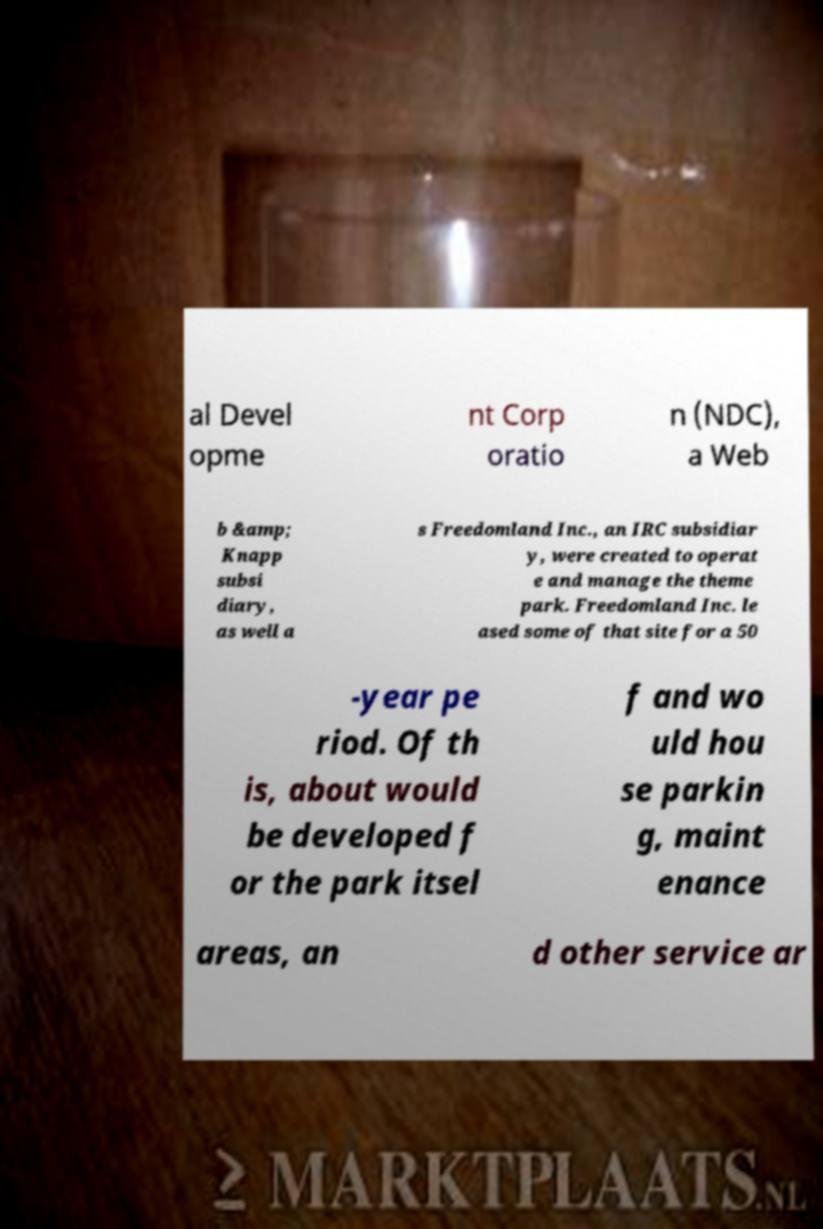Can you accurately transcribe the text from the provided image for me? al Devel opme nt Corp oratio n (NDC), a Web b &amp; Knapp subsi diary, as well a s Freedomland Inc., an IRC subsidiar y, were created to operat e and manage the theme park. Freedomland Inc. le ased some of that site for a 50 -year pe riod. Of th is, about would be developed f or the park itsel f and wo uld hou se parkin g, maint enance areas, an d other service ar 